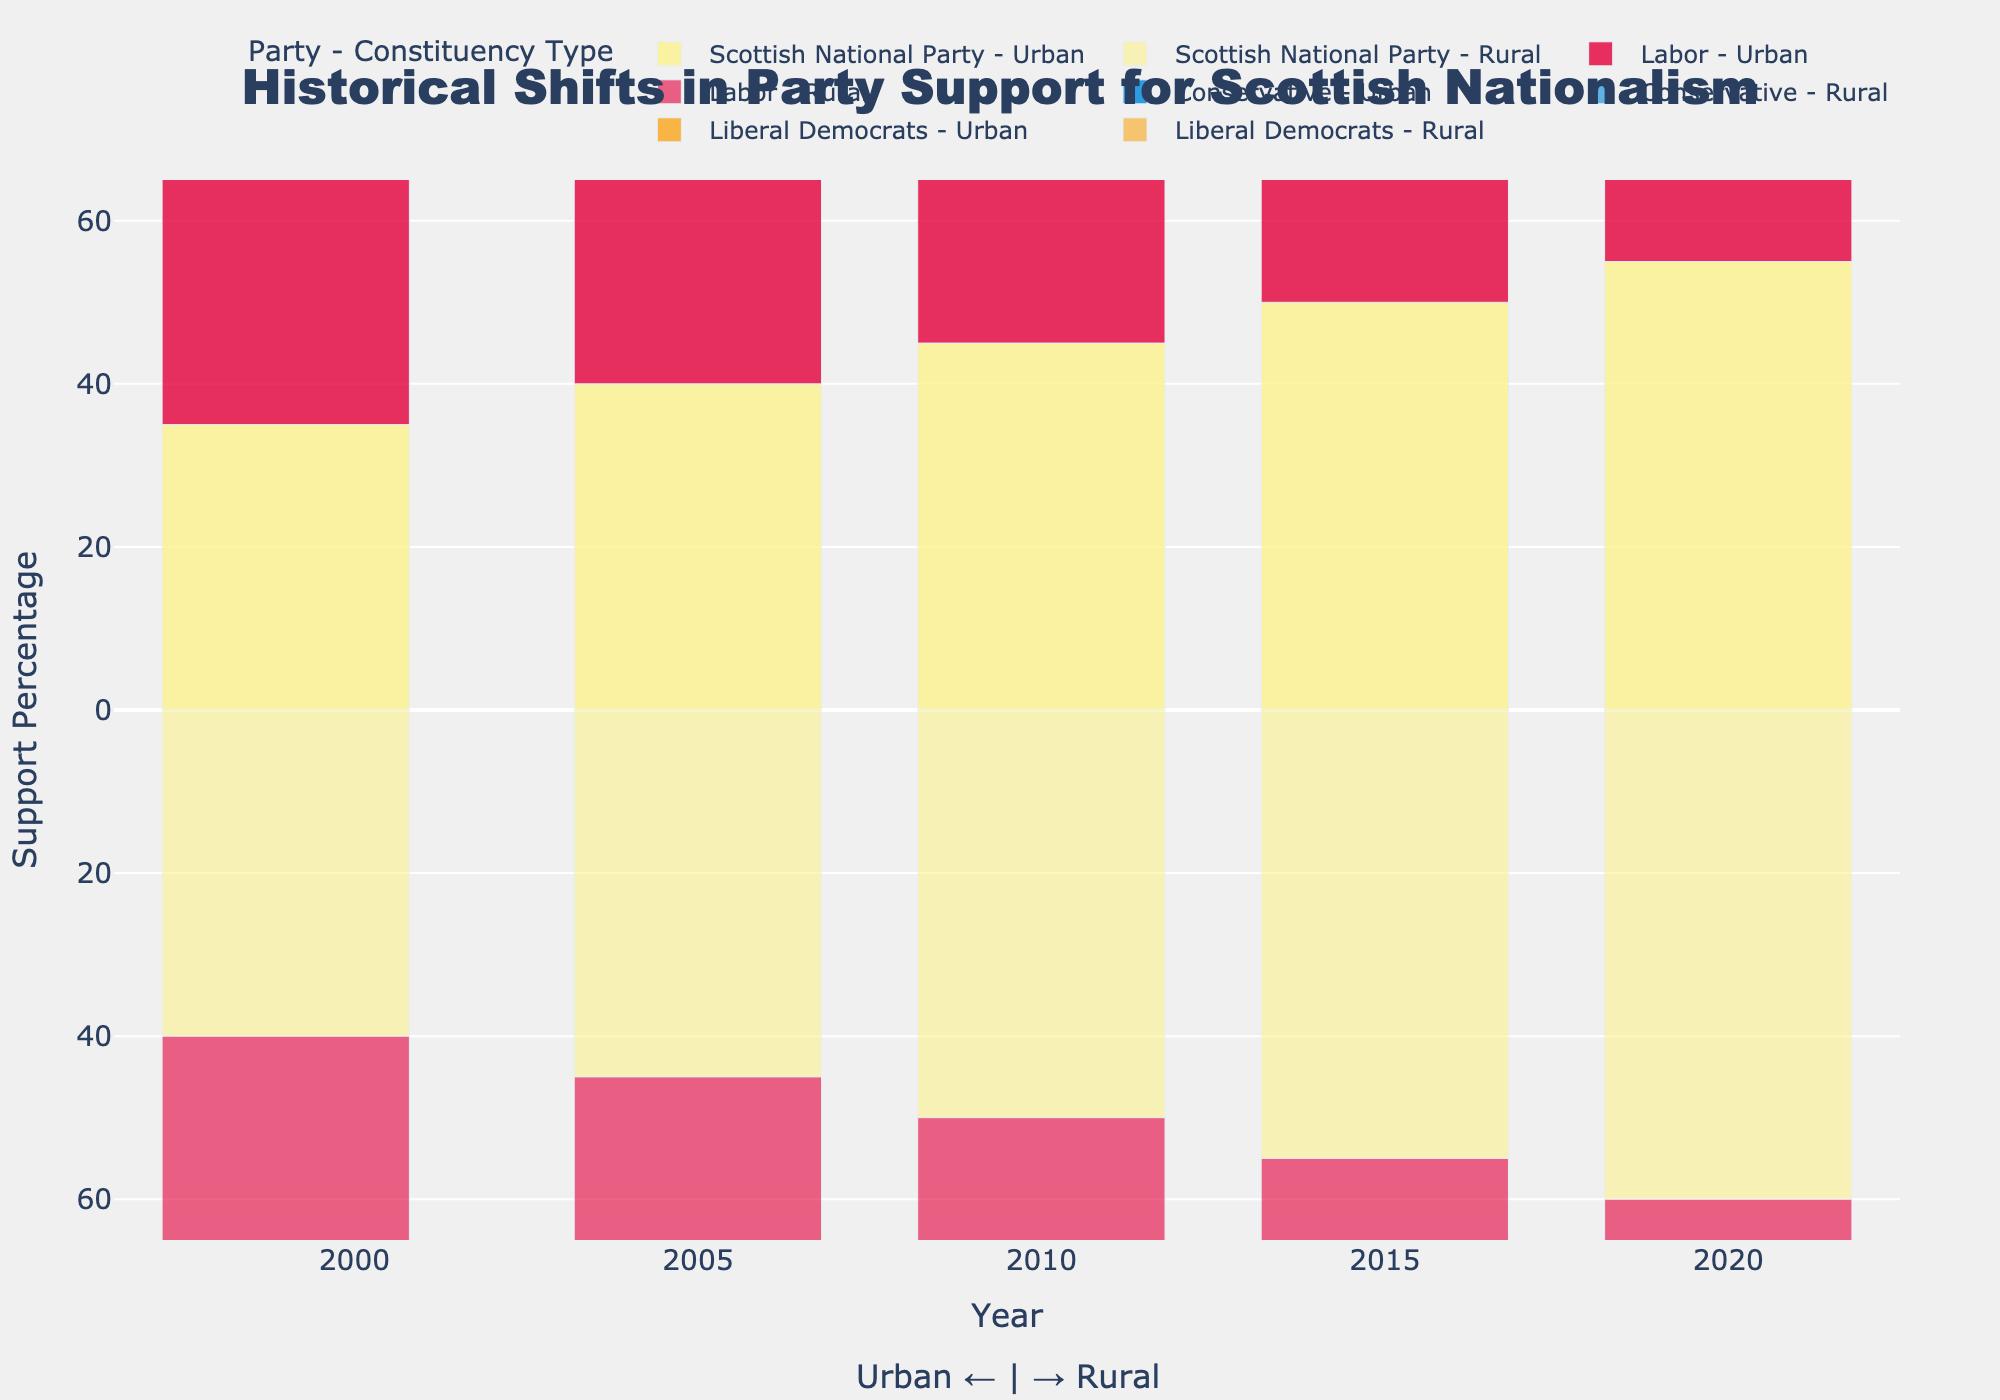Which party gained the most support in rural constituencies from 1999 to 2020? Observe the increase in support percentage for each party in rural constituencies from 1999 to 2020 by looking at the heights of the bars. The Scottish National Party increased from 40% to 60%, showing the largest gain.
Answer: Scottish National Party How did the support for the Labor party in urban constituencies change from 1999 to 2020? Compare the heights of the bars for the Labor party in urban constituencies for the years 1999 and 2020. There was a decrease from 45% to 25%.
Answer: Decreased from 45% to 25% What is the difference in support percentage for the Scottish National Party between urban and rural constituencies in 2020? Look at the heights of the bars representing the Scottish National Party in 2020. In urban areas, the support is 55%, and in rural areas, it is 60%. The difference is 60% - 55% = 5%.
Answer: 5% Which constituency type showed a decrease in support for the Liberal Democrats from 2015 to 2020? Compare the heights of the bars for the Liberal Democrats in urban and rural constituencies from 2015 to 2020. Both urban and rural saw a decrease, but rural constituencies showed a more significant decrease from 10% to 5%.
Answer: Rural Was there ever a year when the Conservative party had the same support percentage in both urban and rural constituencies? Look at the heights of the bars for the Conservative party in both urban and rural areas across all years. The support was the same (10%) in both urban and rural constituencies in 1999, 2005, and 2010.
Answer: Yes, 1999, 2005, and 2010 What was the general trend in support for the Scottish National Party in urban constituencies from 1999 to 2020? Observe the bars representing the Scottish National Party in urban constituencies over the years. The trend indicates a steady increase from 35% in 1999 to 55% in 2020.
Answer: Increasing Compare the support for the Labor party in rural constituencies between 1999 and 2015. Examine the heights of the bars for the Labor party in rural constituencies in 1999 (30%) and 2015 (20%). Calculate the difference, indicating a decrease of 30% - 20% = 10%.
Answer: Decreased by 10% Which party had a stable support percentage in urban constituencies from 1999 to 2020? Look at the heights of the bars for each party in urban constituencies across all years and identify the one with minimal changes. The Conservative party had stable support at 10%.
Answer: Conservative What happened to the support for the Scottish National Party in rural constituencies between 2010 and 2015? Investigate the heights of the bars for the Scottish National Party in rural constituencies for 2010 and 2015. The support increased from 50% to 55%.
Answer: Increased by 5% Which party had the least support in urban constituencies in 2020? Look at the bars for 2020 in urban constituencies to identify the shortest one. The Conservative and Liberal Democrats both had the lowest support at 10%, but since the Conservative remained relatively stable, we give the answer as Liberal Democrats due to its clearer declining trend.
Answer: Liberal Democrats 